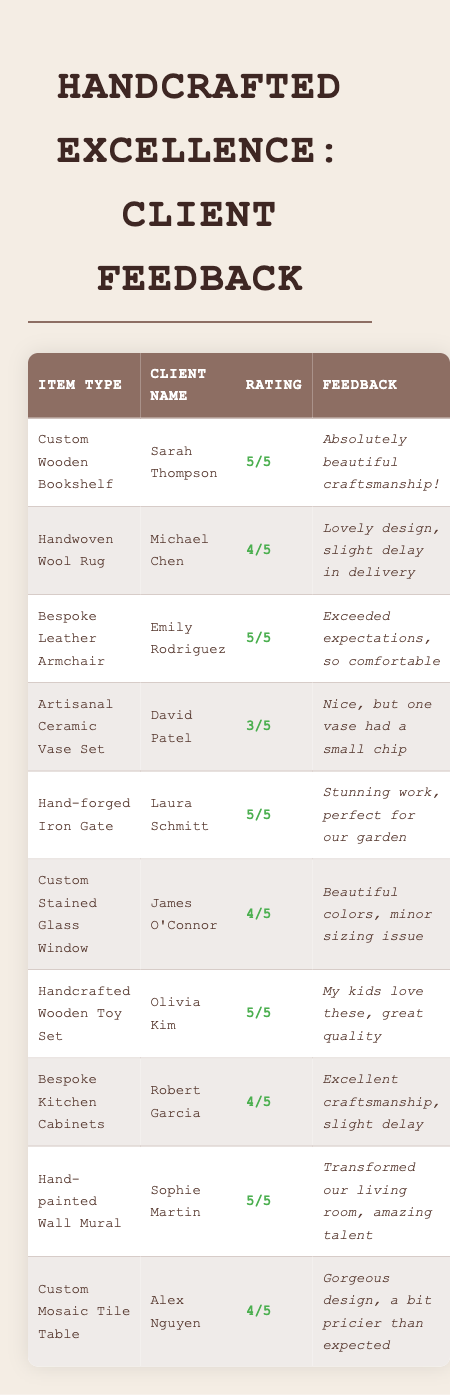What is the highest rating given in the feedback? The highest rating is 5, which was given by Sarah Thompson for the Custom Wooden Bookshelf, Emily Rodriguez for the Bespoke Leather Armchair, Laura Schmitt for the Hand-forged Iron Gate, Olivia Kim for the Handcrafted Wooden Toy Set, and Sophie Martin for the Hand-painted Wall Mural.
Answer: 5 How many items received a rating of 4 or higher? The items that received a rating of 4 or higher are the Custom Wooden Bookshelf, Bespoke Leather Armchair, Hand-forged Iron Gate, Custom Stained Glass Window, Handcrafted Wooden Toy Set, Bespoke Kitchen Cabinets, Hand-painted Wall Mural, and Custom Mosaic Tile Table. That totals to 8 items.
Answer: 8 Which client gave feedback about a product that had a defect? The client who noted a defect was David Patel, who mentioned a small chip in one of the vases from the Artisanal Ceramic Vase Set.
Answer: David Patel What is the average rating of all the handcrafted items? To find the average, we calculate the sum of the ratings (5 + 4 + 5 + 3 + 5 + 4 + 5 + 4 + 5 + 4 = 48) and divide by the number of items (10), leading to an average of 48/10 = 4.8.
Answer: 4.8 Did any items receive a rating of 3? Yes, the Artisanal Ceramic Vase Set received a rating of 3.
Answer: Yes Which item received the lowest rating and what was the feedback? The item with the lowest rating is the Artisanal Ceramic Vase Set, which received a rating of 3, and the feedback included that "one vase had a small chip."
Answer: Artisanal Ceramic Vase Set; one vase had a small chip How many clients mentioned any delivery delays in their feedback? Michael Chen and Robert Garcia both mentioned delivery delays in their feedback. Michael mentioned a slight delay for the Handwoven Wool Rug, and Robert noted a slight delay for the Bespoke Kitchen Cabinets, resulting in a total of 2 clients.
Answer: 2 What percentage of items received a rating of 5? There are 10 total items, and 5 of them received a rating of 5. To find the percentage, we use (5/10) * 100 = 50%, meaning 50% of items received a rating of 5.
Answer: 50% 